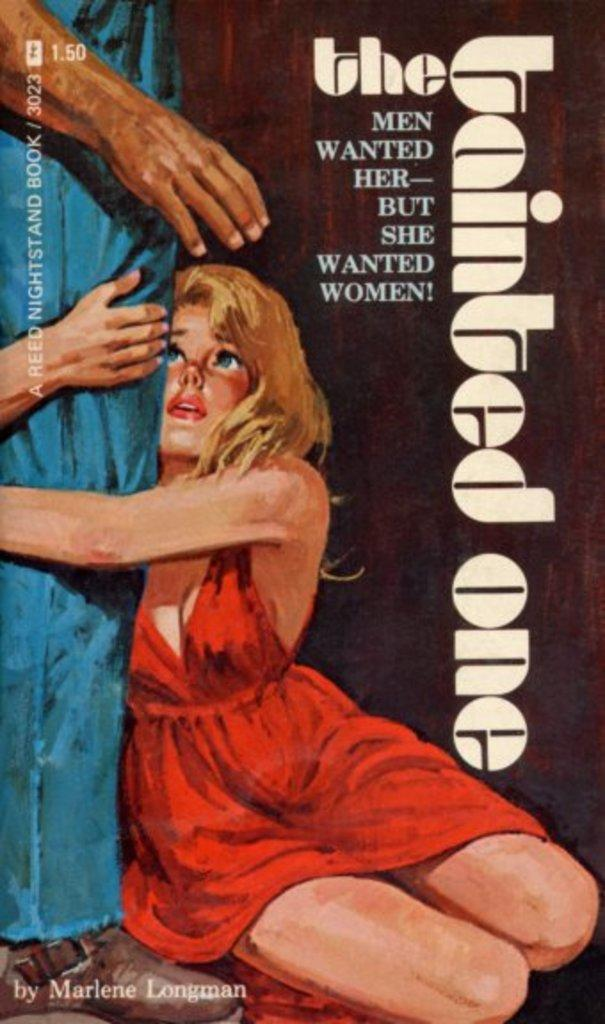<image>
Write a terse but informative summary of the picture. A book by Marlene Longman shows a woman on the cover. 